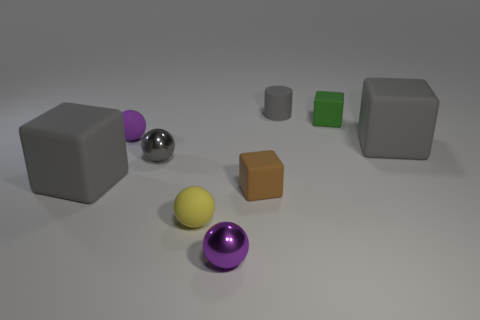Subtract all red balls. Subtract all green cylinders. How many balls are left? 4 Add 1 small cyan shiny cylinders. How many objects exist? 10 Subtract all blocks. How many objects are left? 5 Subtract 0 red cylinders. How many objects are left? 9 Subtract all blocks. Subtract all blue matte cubes. How many objects are left? 5 Add 8 tiny brown matte blocks. How many tiny brown matte blocks are left? 9 Add 5 purple objects. How many purple objects exist? 7 